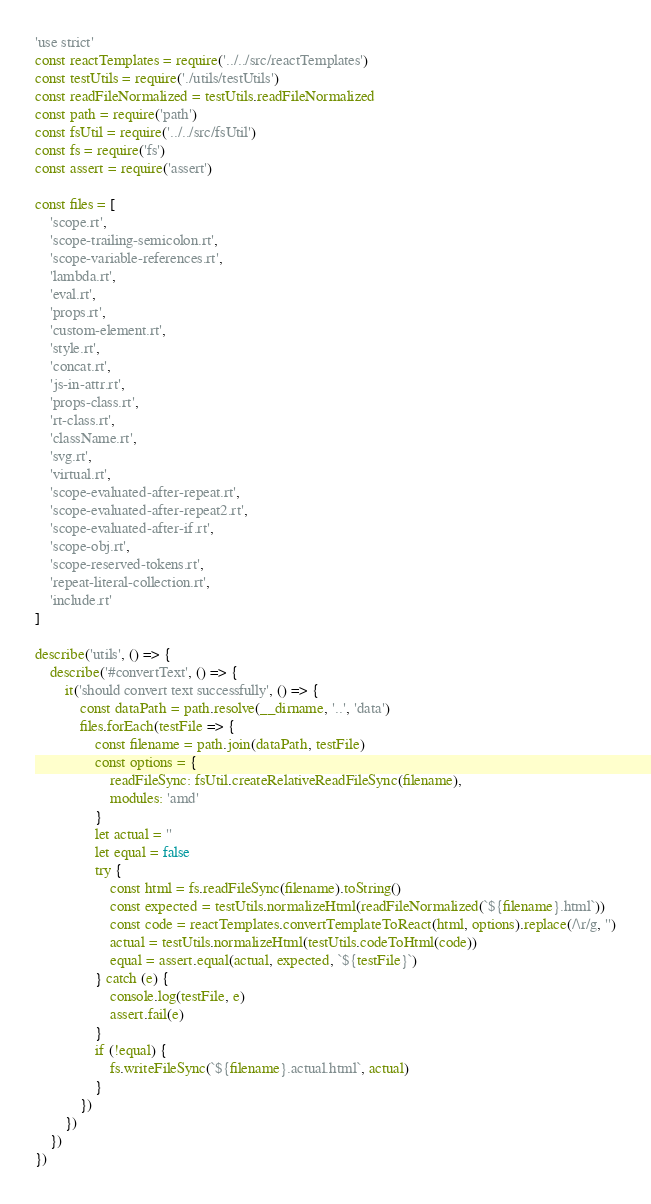<code> <loc_0><loc_0><loc_500><loc_500><_JavaScript_>'use strict'
const reactTemplates = require('../../src/reactTemplates')
const testUtils = require('./utils/testUtils')
const readFileNormalized = testUtils.readFileNormalized
const path = require('path')
const fsUtil = require('../../src/fsUtil')
const fs = require('fs')
const assert = require('assert')

const files = [
    'scope.rt',
    'scope-trailing-semicolon.rt',
    'scope-variable-references.rt',
    'lambda.rt',
    'eval.rt',
    'props.rt',
    'custom-element.rt',
    'style.rt',
    'concat.rt',
    'js-in-attr.rt',
    'props-class.rt',
    'rt-class.rt',
    'className.rt',
    'svg.rt',
    'virtual.rt',
    'scope-evaluated-after-repeat.rt',
    'scope-evaluated-after-repeat2.rt',
    'scope-evaluated-after-if.rt',
    'scope-obj.rt',
    'scope-reserved-tokens.rt',
    'repeat-literal-collection.rt',
    'include.rt'
]

describe('utils', () => {
    describe('#convertText', () => {
        it('should convert text successfully', () => {
            const dataPath = path.resolve(__dirname, '..', 'data')
            files.forEach(testFile => {
                const filename = path.join(dataPath, testFile)
                const options = {
                    readFileSync: fsUtil.createRelativeReadFileSync(filename),
                    modules: 'amd'
                }
                let actual = ''
                let equal = false
                try {
                    const html = fs.readFileSync(filename).toString()
                    const expected = testUtils.normalizeHtml(readFileNormalized(`${filename}.html`))
                    const code = reactTemplates.convertTemplateToReact(html, options).replace(/\r/g, '')
                    actual = testUtils.normalizeHtml(testUtils.codeToHtml(code))
                    equal = assert.equal(actual, expected, `${testFile}`)
                } catch (e) {
                    console.log(testFile, e)
                    assert.fail(e)
                }
                if (!equal) {
                    fs.writeFileSync(`${filename}.actual.html`, actual)
                }
            })
        })
    })
})
</code> 